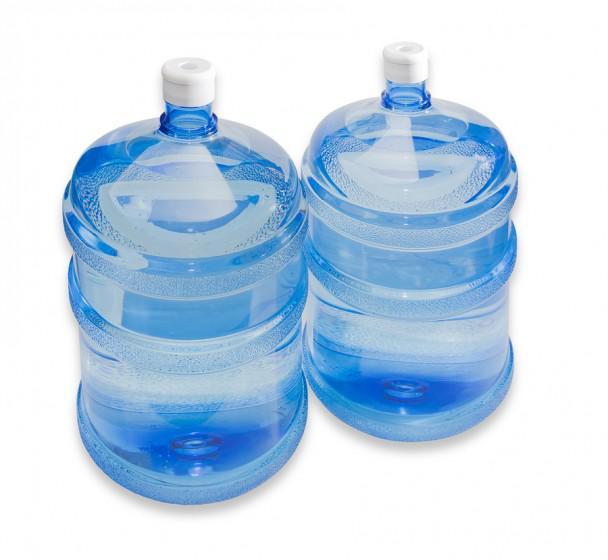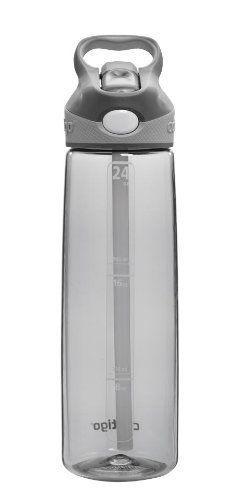The first image is the image on the left, the second image is the image on the right. For the images displayed, is the sentence "An image shows at least one stout translucent blue water jug with a lid on it." factually correct? Answer yes or no. Yes. The first image is the image on the left, the second image is the image on the right. For the images shown, is this caption "At least one wide blue tinted bottle with a plastic cap is shown in one image, while a second image shows a personal water bottle with detachable cap." true? Answer yes or no. Yes. 